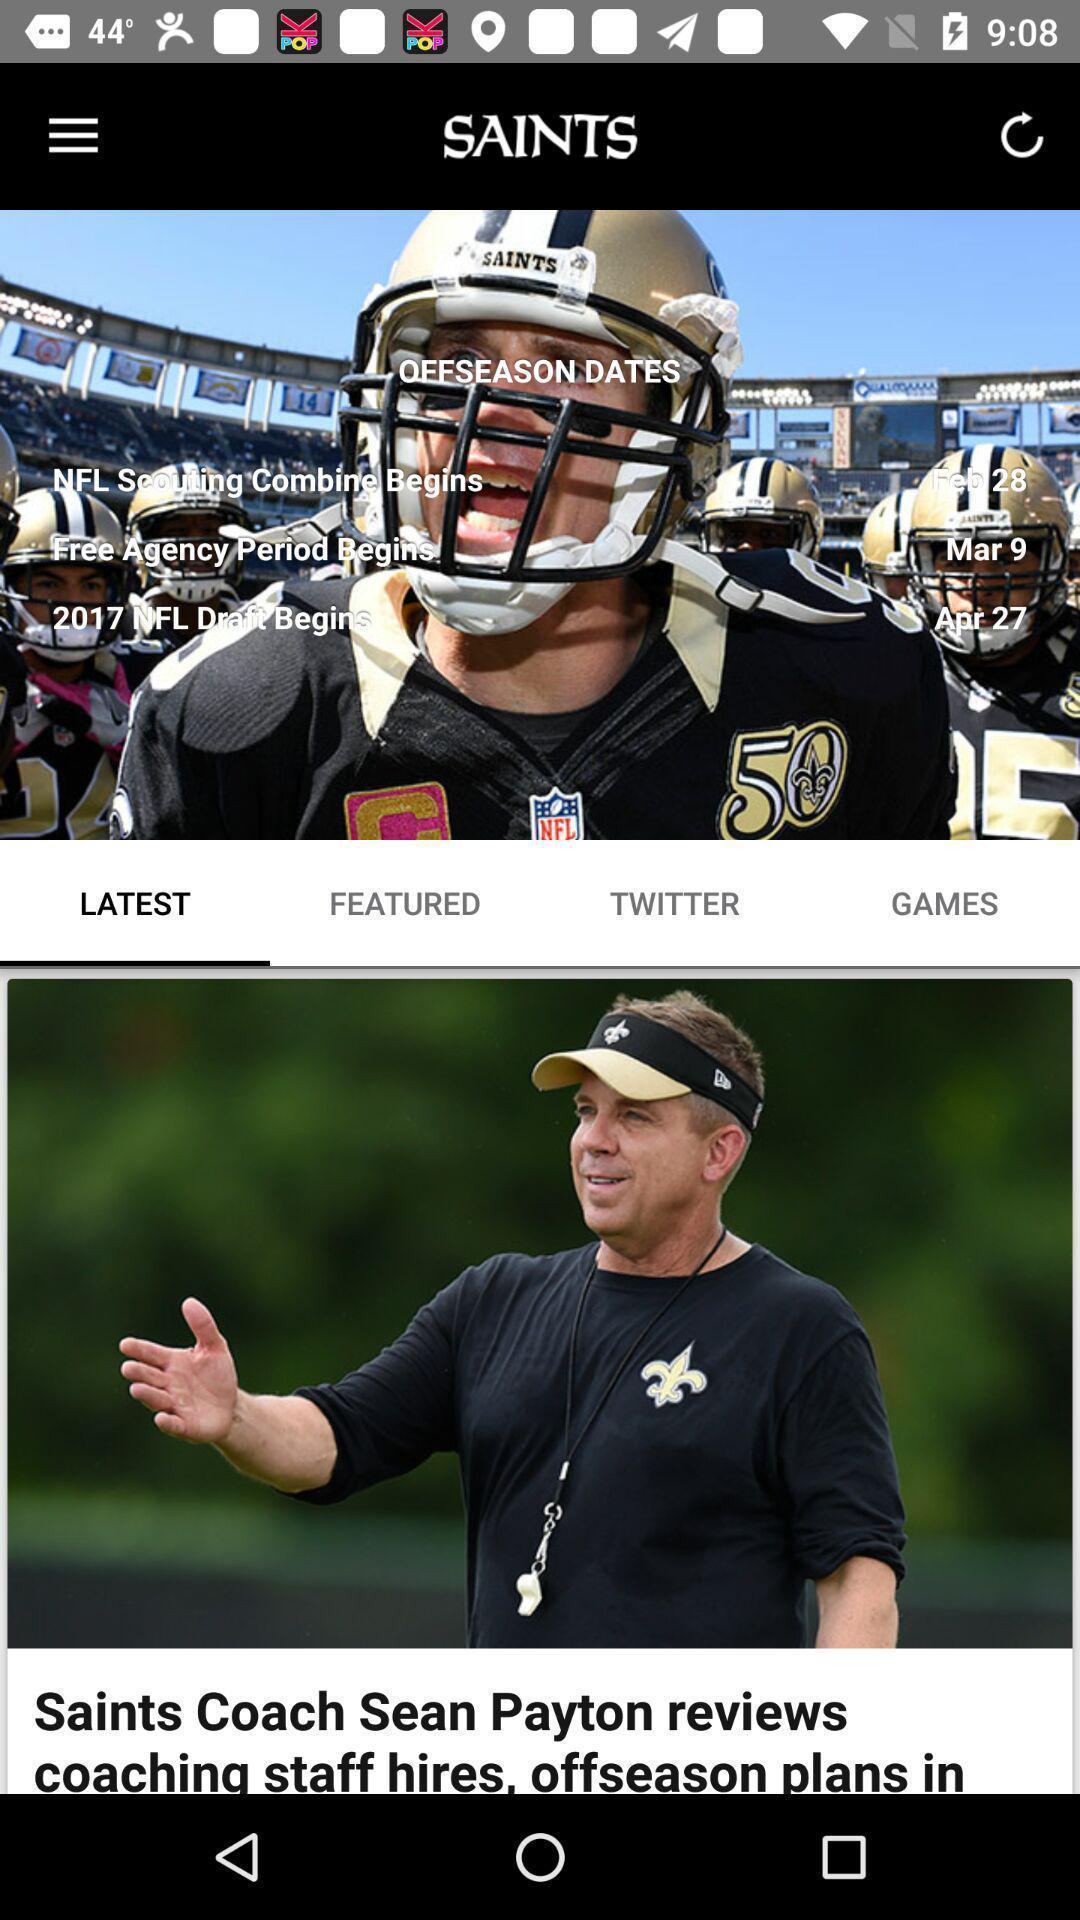Please provide a description for this image. Page showing real-time breaking news from the saints. 